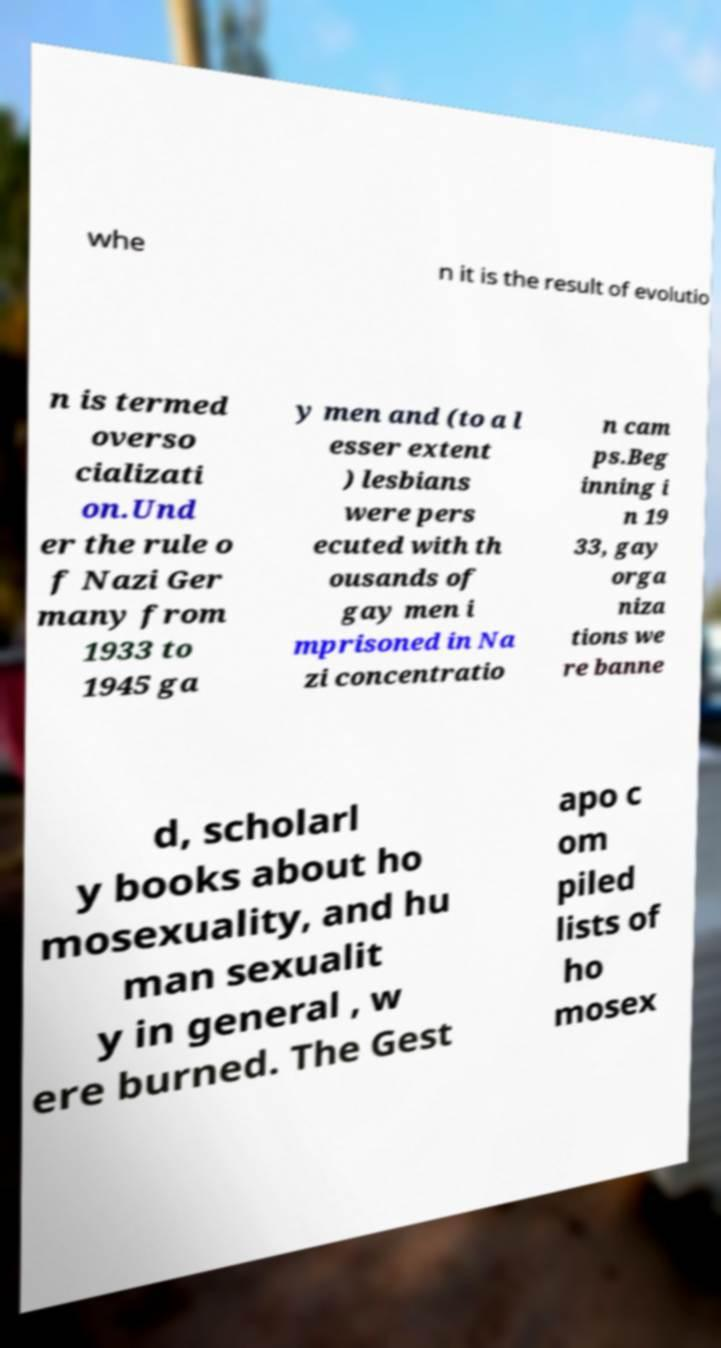There's text embedded in this image that I need extracted. Can you transcribe it verbatim? whe n it is the result of evolutio n is termed overso cializati on.Und er the rule o f Nazi Ger many from 1933 to 1945 ga y men and (to a l esser extent ) lesbians were pers ecuted with th ousands of gay men i mprisoned in Na zi concentratio n cam ps.Beg inning i n 19 33, gay orga niza tions we re banne d, scholarl y books about ho mosexuality, and hu man sexualit y in general , w ere burned. The Gest apo c om piled lists of ho mosex 